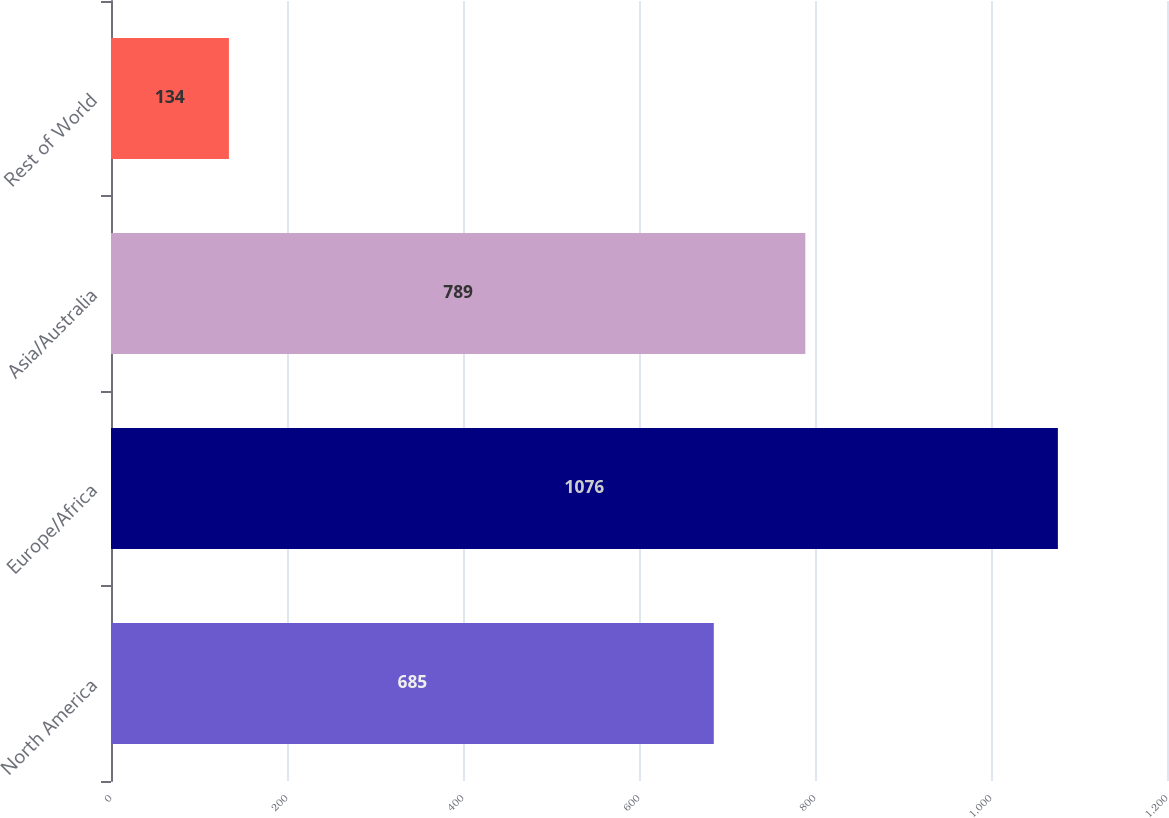<chart> <loc_0><loc_0><loc_500><loc_500><bar_chart><fcel>North America<fcel>Europe/Africa<fcel>Asia/Australia<fcel>Rest of World<nl><fcel>685<fcel>1076<fcel>789<fcel>134<nl></chart> 